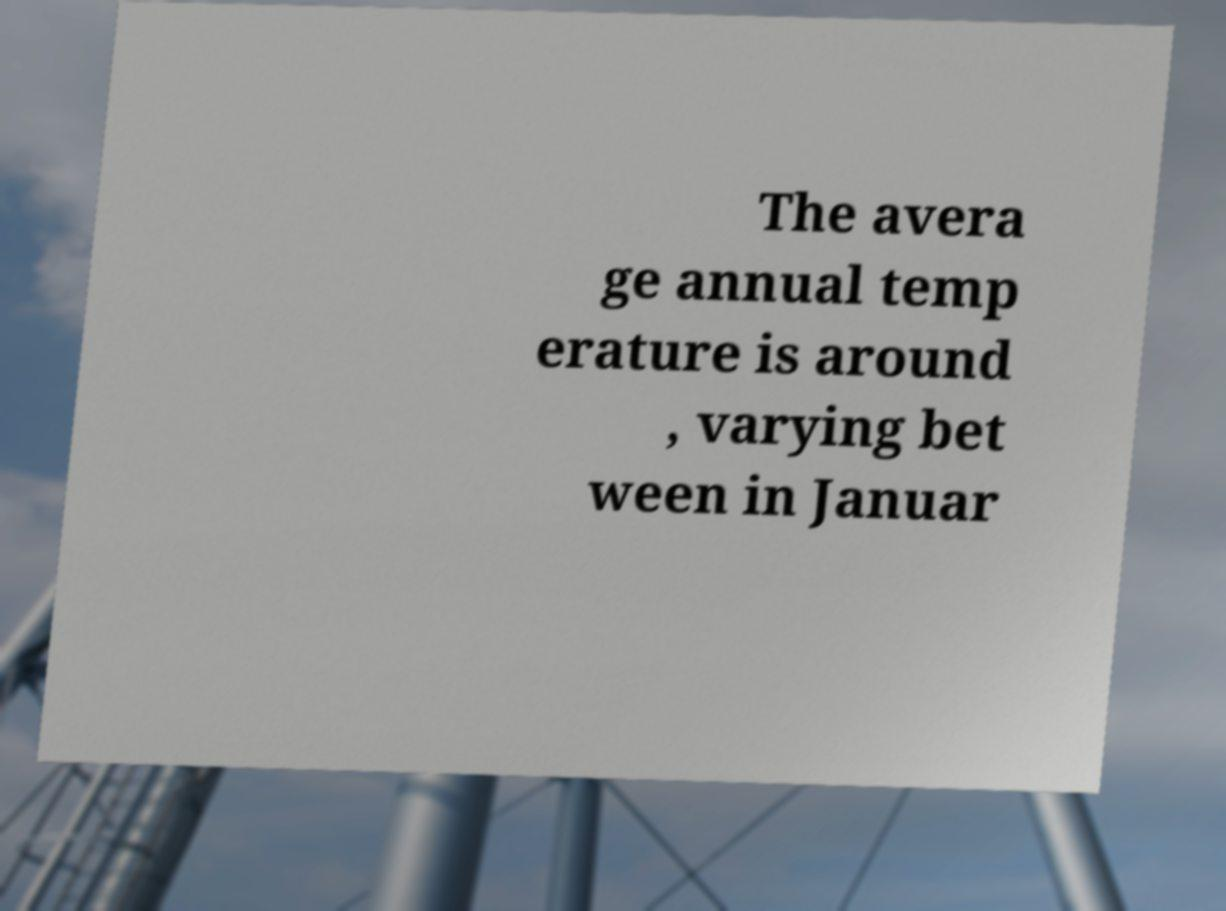Please read and relay the text visible in this image. What does it say? The avera ge annual temp erature is around , varying bet ween in Januar 